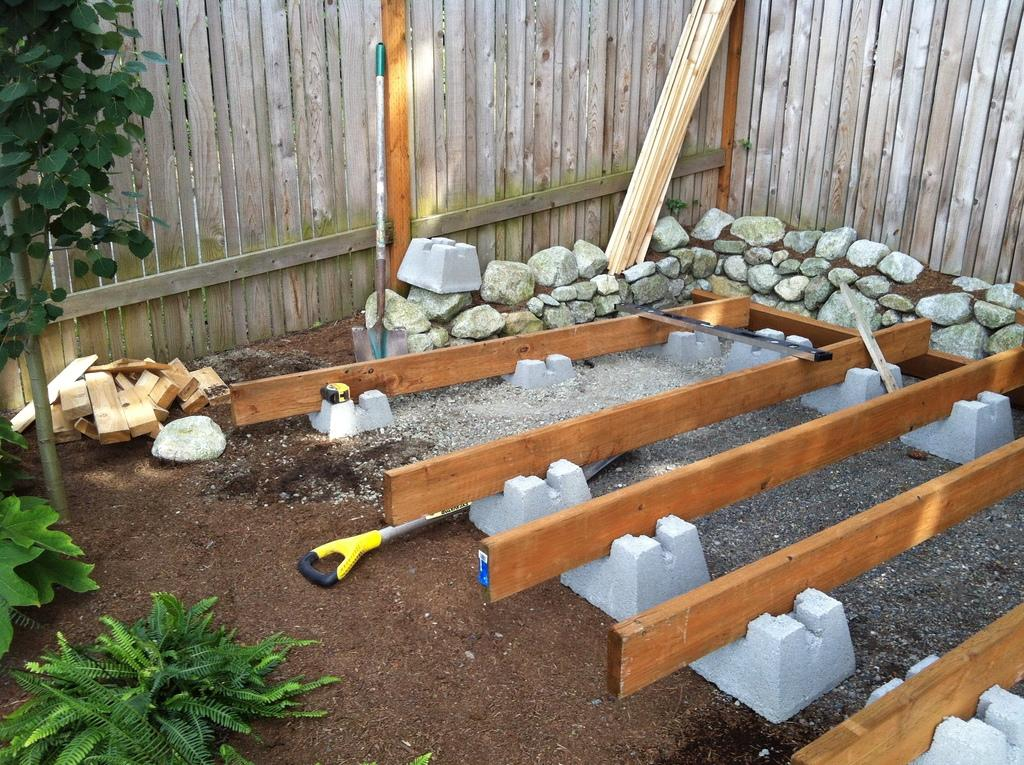What type of natural elements can be seen in the image? There are rocks in the image. What type of man-made objects can be seen in the image? There are wooden objects in the image. Where is the fence wall located in the image? The fence wall is in the right corner of the image. What type of vegetation can be seen in the image? There are plants in the left corner of the image. What type of road can be seen in the image? There is no road present in the image. What type of sign is visible in the image? There is no sign visible in the image. 